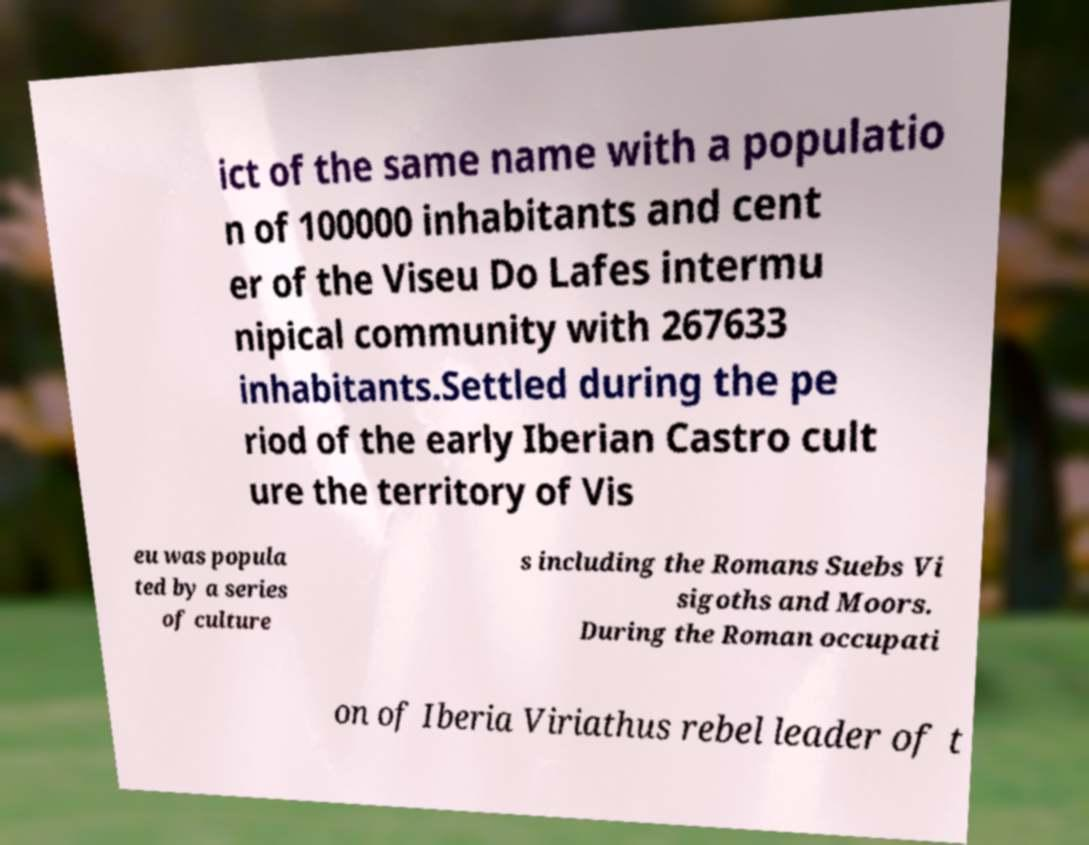What messages or text are displayed in this image? I need them in a readable, typed format. ict of the same name with a populatio n of 100000 inhabitants and cent er of the Viseu Do Lafes intermu nipical community with 267633 inhabitants.Settled during the pe riod of the early Iberian Castro cult ure the territory of Vis eu was popula ted by a series of culture s including the Romans Suebs Vi sigoths and Moors. During the Roman occupati on of Iberia Viriathus rebel leader of t 